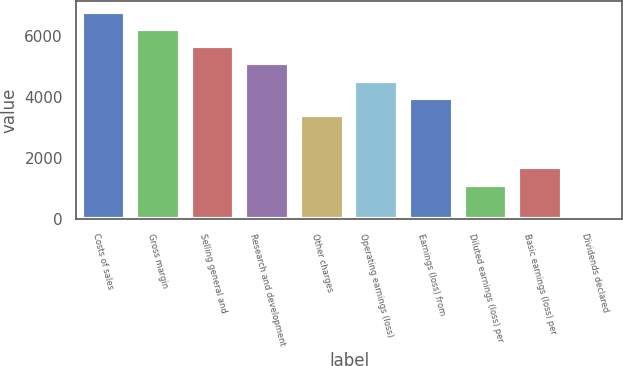Convert chart to OTSL. <chart><loc_0><loc_0><loc_500><loc_500><bar_chart><fcel>Costs of sales<fcel>Gross margin<fcel>Selling general and<fcel>Research and development<fcel>Other charges<fcel>Operating earnings (loss)<fcel>Earnings (loss) from<fcel>Diluted earnings (loss) per<fcel>Basic earnings (loss) per<fcel>Dividends declared<nl><fcel>6812.39<fcel>6244.7<fcel>5677.01<fcel>5109.31<fcel>3406.24<fcel>4541.62<fcel>3973.93<fcel>1135.45<fcel>1703.14<fcel>0.05<nl></chart> 